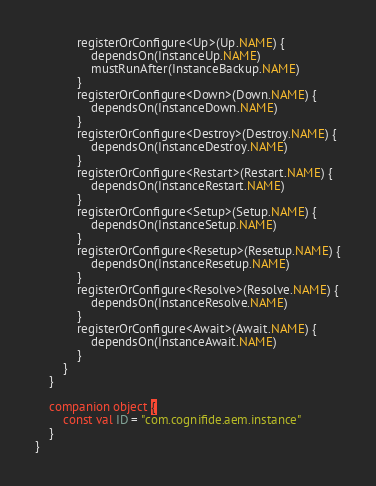Convert code to text. <code><loc_0><loc_0><loc_500><loc_500><_Kotlin_>            registerOrConfigure<Up>(Up.NAME) {
                dependsOn(InstanceUp.NAME)
                mustRunAfter(InstanceBackup.NAME)
            }
            registerOrConfigure<Down>(Down.NAME) {
                dependsOn(InstanceDown.NAME)
            }
            registerOrConfigure<Destroy>(Destroy.NAME) {
                dependsOn(InstanceDestroy.NAME)
            }
            registerOrConfigure<Restart>(Restart.NAME) {
                dependsOn(InstanceRestart.NAME)
            }
            registerOrConfigure<Setup>(Setup.NAME) {
                dependsOn(InstanceSetup.NAME)
            }
            registerOrConfigure<Resetup>(Resetup.NAME) {
                dependsOn(InstanceResetup.NAME)
            }
            registerOrConfigure<Resolve>(Resolve.NAME) {
                dependsOn(InstanceResolve.NAME)
            }
            registerOrConfigure<Await>(Await.NAME) {
                dependsOn(InstanceAwait.NAME)
            }
        }
    }

    companion object {
        const val ID = "com.cognifide.aem.instance"
    }
}
</code> 